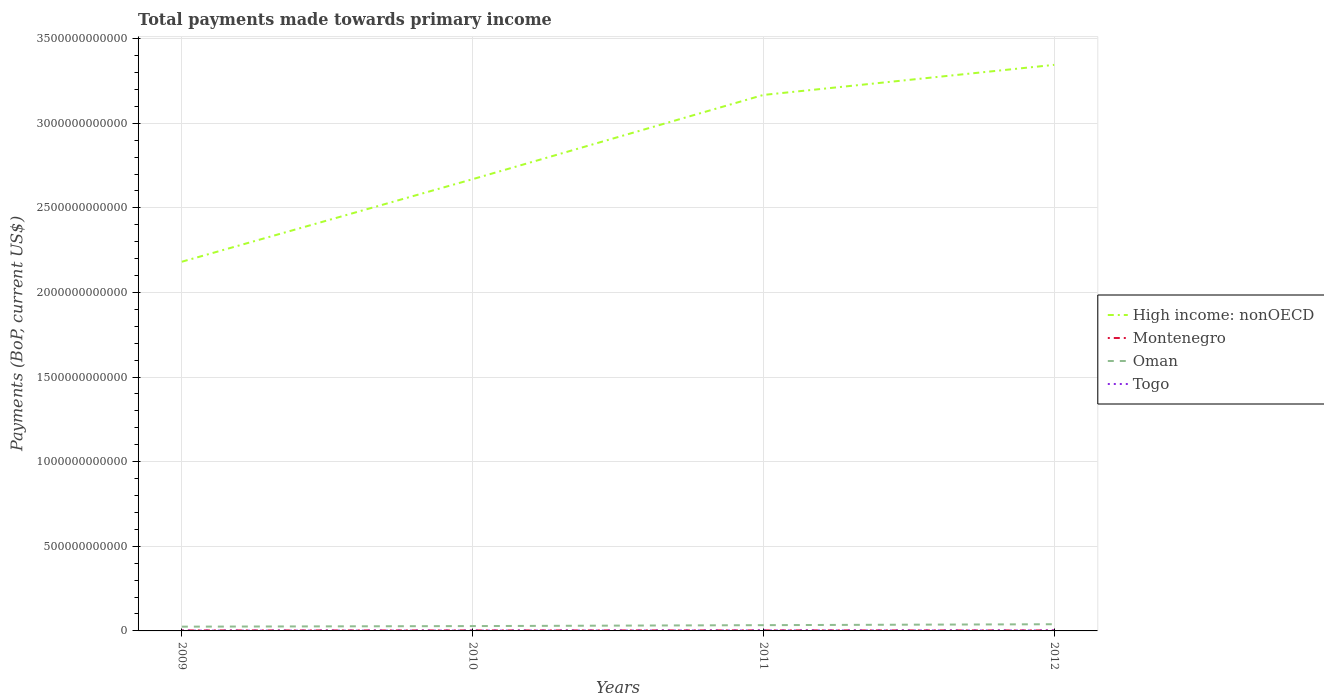How many different coloured lines are there?
Make the answer very short. 4. Is the number of lines equal to the number of legend labels?
Provide a succinct answer. Yes. Across all years, what is the maximum total payments made towards primary income in Oman?
Ensure brevity in your answer.  2.52e+1. In which year was the total payments made towards primary income in Togo maximum?
Your answer should be compact. 2009. What is the total total payments made towards primary income in Oman in the graph?
Offer a terse response. -1.10e+1. What is the difference between the highest and the second highest total payments made towards primary income in Montenegro?
Provide a short and direct response. 3.26e+08. What is the difference between the highest and the lowest total payments made towards primary income in High income: nonOECD?
Provide a short and direct response. 2. How many years are there in the graph?
Offer a terse response. 4. What is the difference between two consecutive major ticks on the Y-axis?
Offer a terse response. 5.00e+11. Does the graph contain any zero values?
Your response must be concise. No. Does the graph contain grids?
Provide a short and direct response. Yes. Where does the legend appear in the graph?
Your answer should be very brief. Center right. How many legend labels are there?
Your response must be concise. 4. What is the title of the graph?
Provide a short and direct response. Total payments made towards primary income. Does "Jordan" appear as one of the legend labels in the graph?
Give a very brief answer. No. What is the label or title of the X-axis?
Your answer should be compact. Years. What is the label or title of the Y-axis?
Your answer should be compact. Payments (BoP, current US$). What is the Payments (BoP, current US$) of High income: nonOECD in 2009?
Offer a very short reply. 2.18e+12. What is the Payments (BoP, current US$) of Montenegro in 2009?
Provide a short and direct response. 2.93e+09. What is the Payments (BoP, current US$) in Oman in 2009?
Your answer should be compact. 2.52e+1. What is the Payments (BoP, current US$) in Togo in 2009?
Make the answer very short. 1.78e+09. What is the Payments (BoP, current US$) of High income: nonOECD in 2010?
Keep it short and to the point. 2.67e+12. What is the Payments (BoP, current US$) of Montenegro in 2010?
Offer a terse response. 2.83e+09. What is the Payments (BoP, current US$) of Oman in 2010?
Offer a terse response. 2.86e+1. What is the Payments (BoP, current US$) in Togo in 2010?
Keep it short and to the point. 1.95e+09. What is the Payments (BoP, current US$) in High income: nonOECD in 2011?
Provide a succinct answer. 3.17e+12. What is the Payments (BoP, current US$) in Montenegro in 2011?
Ensure brevity in your answer.  3.15e+09. What is the Payments (BoP, current US$) of Oman in 2011?
Offer a terse response. 3.41e+1. What is the Payments (BoP, current US$) of Togo in 2011?
Give a very brief answer. 2.65e+09. What is the Payments (BoP, current US$) in High income: nonOECD in 2012?
Provide a succinct answer. 3.34e+12. What is the Payments (BoP, current US$) in Montenegro in 2012?
Provide a succinct answer. 2.92e+09. What is the Payments (BoP, current US$) in Oman in 2012?
Provide a short and direct response. 3.96e+1. What is the Payments (BoP, current US$) of Togo in 2012?
Offer a very short reply. 2.54e+09. Across all years, what is the maximum Payments (BoP, current US$) in High income: nonOECD?
Ensure brevity in your answer.  3.34e+12. Across all years, what is the maximum Payments (BoP, current US$) in Montenegro?
Keep it short and to the point. 3.15e+09. Across all years, what is the maximum Payments (BoP, current US$) in Oman?
Provide a succinct answer. 3.96e+1. Across all years, what is the maximum Payments (BoP, current US$) in Togo?
Make the answer very short. 2.65e+09. Across all years, what is the minimum Payments (BoP, current US$) in High income: nonOECD?
Offer a very short reply. 2.18e+12. Across all years, what is the minimum Payments (BoP, current US$) in Montenegro?
Offer a very short reply. 2.83e+09. Across all years, what is the minimum Payments (BoP, current US$) of Oman?
Make the answer very short. 2.52e+1. Across all years, what is the minimum Payments (BoP, current US$) of Togo?
Offer a terse response. 1.78e+09. What is the total Payments (BoP, current US$) in High income: nonOECD in the graph?
Give a very brief answer. 1.14e+13. What is the total Payments (BoP, current US$) in Montenegro in the graph?
Your answer should be compact. 1.18e+1. What is the total Payments (BoP, current US$) in Oman in the graph?
Keep it short and to the point. 1.27e+11. What is the total Payments (BoP, current US$) in Togo in the graph?
Offer a very short reply. 8.92e+09. What is the difference between the Payments (BoP, current US$) of High income: nonOECD in 2009 and that in 2010?
Provide a succinct answer. -4.88e+11. What is the difference between the Payments (BoP, current US$) of Montenegro in 2009 and that in 2010?
Keep it short and to the point. 1.07e+08. What is the difference between the Payments (BoP, current US$) of Oman in 2009 and that in 2010?
Ensure brevity in your answer.  -3.38e+09. What is the difference between the Payments (BoP, current US$) of Togo in 2009 and that in 2010?
Provide a succinct answer. -1.74e+08. What is the difference between the Payments (BoP, current US$) in High income: nonOECD in 2009 and that in 2011?
Ensure brevity in your answer.  -9.86e+11. What is the difference between the Payments (BoP, current US$) in Montenegro in 2009 and that in 2011?
Your answer should be very brief. -2.19e+08. What is the difference between the Payments (BoP, current US$) of Oman in 2009 and that in 2011?
Your answer should be very brief. -8.90e+09. What is the difference between the Payments (BoP, current US$) of Togo in 2009 and that in 2011?
Make the answer very short. -8.74e+08. What is the difference between the Payments (BoP, current US$) in High income: nonOECD in 2009 and that in 2012?
Keep it short and to the point. -1.16e+12. What is the difference between the Payments (BoP, current US$) of Montenegro in 2009 and that in 2012?
Offer a terse response. 1.51e+07. What is the difference between the Payments (BoP, current US$) of Oman in 2009 and that in 2012?
Make the answer very short. -1.43e+1. What is the difference between the Payments (BoP, current US$) of Togo in 2009 and that in 2012?
Offer a terse response. -7.64e+08. What is the difference between the Payments (BoP, current US$) of High income: nonOECD in 2010 and that in 2011?
Offer a terse response. -4.98e+11. What is the difference between the Payments (BoP, current US$) of Montenegro in 2010 and that in 2011?
Offer a terse response. -3.26e+08. What is the difference between the Payments (BoP, current US$) in Oman in 2010 and that in 2011?
Offer a very short reply. -5.52e+09. What is the difference between the Payments (BoP, current US$) in Togo in 2010 and that in 2011?
Offer a very short reply. -7.00e+08. What is the difference between the Payments (BoP, current US$) of High income: nonOECD in 2010 and that in 2012?
Your response must be concise. -6.76e+11. What is the difference between the Payments (BoP, current US$) in Montenegro in 2010 and that in 2012?
Make the answer very short. -9.16e+07. What is the difference between the Payments (BoP, current US$) in Oman in 2010 and that in 2012?
Ensure brevity in your answer.  -1.10e+1. What is the difference between the Payments (BoP, current US$) of Togo in 2010 and that in 2012?
Provide a short and direct response. -5.90e+08. What is the difference between the Payments (BoP, current US$) in High income: nonOECD in 2011 and that in 2012?
Give a very brief answer. -1.78e+11. What is the difference between the Payments (BoP, current US$) of Montenegro in 2011 and that in 2012?
Provide a short and direct response. 2.34e+08. What is the difference between the Payments (BoP, current US$) in Oman in 2011 and that in 2012?
Your answer should be very brief. -5.45e+09. What is the difference between the Payments (BoP, current US$) in Togo in 2011 and that in 2012?
Ensure brevity in your answer.  1.10e+08. What is the difference between the Payments (BoP, current US$) in High income: nonOECD in 2009 and the Payments (BoP, current US$) in Montenegro in 2010?
Provide a succinct answer. 2.18e+12. What is the difference between the Payments (BoP, current US$) in High income: nonOECD in 2009 and the Payments (BoP, current US$) in Oman in 2010?
Make the answer very short. 2.15e+12. What is the difference between the Payments (BoP, current US$) in High income: nonOECD in 2009 and the Payments (BoP, current US$) in Togo in 2010?
Provide a succinct answer. 2.18e+12. What is the difference between the Payments (BoP, current US$) of Montenegro in 2009 and the Payments (BoP, current US$) of Oman in 2010?
Your answer should be very brief. -2.57e+1. What is the difference between the Payments (BoP, current US$) of Montenegro in 2009 and the Payments (BoP, current US$) of Togo in 2010?
Give a very brief answer. 9.82e+08. What is the difference between the Payments (BoP, current US$) in Oman in 2009 and the Payments (BoP, current US$) in Togo in 2010?
Provide a succinct answer. 2.33e+1. What is the difference between the Payments (BoP, current US$) in High income: nonOECD in 2009 and the Payments (BoP, current US$) in Montenegro in 2011?
Your answer should be very brief. 2.18e+12. What is the difference between the Payments (BoP, current US$) of High income: nonOECD in 2009 and the Payments (BoP, current US$) of Oman in 2011?
Offer a terse response. 2.15e+12. What is the difference between the Payments (BoP, current US$) in High income: nonOECD in 2009 and the Payments (BoP, current US$) in Togo in 2011?
Give a very brief answer. 2.18e+12. What is the difference between the Payments (BoP, current US$) of Montenegro in 2009 and the Payments (BoP, current US$) of Oman in 2011?
Your response must be concise. -3.12e+1. What is the difference between the Payments (BoP, current US$) in Montenegro in 2009 and the Payments (BoP, current US$) in Togo in 2011?
Make the answer very short. 2.82e+08. What is the difference between the Payments (BoP, current US$) of Oman in 2009 and the Payments (BoP, current US$) of Togo in 2011?
Make the answer very short. 2.26e+1. What is the difference between the Payments (BoP, current US$) in High income: nonOECD in 2009 and the Payments (BoP, current US$) in Montenegro in 2012?
Your response must be concise. 2.18e+12. What is the difference between the Payments (BoP, current US$) in High income: nonOECD in 2009 and the Payments (BoP, current US$) in Oman in 2012?
Your response must be concise. 2.14e+12. What is the difference between the Payments (BoP, current US$) in High income: nonOECD in 2009 and the Payments (BoP, current US$) in Togo in 2012?
Your answer should be very brief. 2.18e+12. What is the difference between the Payments (BoP, current US$) of Montenegro in 2009 and the Payments (BoP, current US$) of Oman in 2012?
Make the answer very short. -3.66e+1. What is the difference between the Payments (BoP, current US$) in Montenegro in 2009 and the Payments (BoP, current US$) in Togo in 2012?
Provide a succinct answer. 3.92e+08. What is the difference between the Payments (BoP, current US$) of Oman in 2009 and the Payments (BoP, current US$) of Togo in 2012?
Your answer should be very brief. 2.27e+1. What is the difference between the Payments (BoP, current US$) in High income: nonOECD in 2010 and the Payments (BoP, current US$) in Montenegro in 2011?
Offer a very short reply. 2.67e+12. What is the difference between the Payments (BoP, current US$) of High income: nonOECD in 2010 and the Payments (BoP, current US$) of Oman in 2011?
Ensure brevity in your answer.  2.64e+12. What is the difference between the Payments (BoP, current US$) of High income: nonOECD in 2010 and the Payments (BoP, current US$) of Togo in 2011?
Offer a very short reply. 2.67e+12. What is the difference between the Payments (BoP, current US$) of Montenegro in 2010 and the Payments (BoP, current US$) of Oman in 2011?
Your answer should be very brief. -3.13e+1. What is the difference between the Payments (BoP, current US$) of Montenegro in 2010 and the Payments (BoP, current US$) of Togo in 2011?
Your answer should be very brief. 1.75e+08. What is the difference between the Payments (BoP, current US$) of Oman in 2010 and the Payments (BoP, current US$) of Togo in 2011?
Give a very brief answer. 2.59e+1. What is the difference between the Payments (BoP, current US$) in High income: nonOECD in 2010 and the Payments (BoP, current US$) in Montenegro in 2012?
Your answer should be compact. 2.67e+12. What is the difference between the Payments (BoP, current US$) in High income: nonOECD in 2010 and the Payments (BoP, current US$) in Oman in 2012?
Your answer should be compact. 2.63e+12. What is the difference between the Payments (BoP, current US$) in High income: nonOECD in 2010 and the Payments (BoP, current US$) in Togo in 2012?
Keep it short and to the point. 2.67e+12. What is the difference between the Payments (BoP, current US$) of Montenegro in 2010 and the Payments (BoP, current US$) of Oman in 2012?
Provide a short and direct response. -3.67e+1. What is the difference between the Payments (BoP, current US$) in Montenegro in 2010 and the Payments (BoP, current US$) in Togo in 2012?
Provide a short and direct response. 2.85e+08. What is the difference between the Payments (BoP, current US$) in Oman in 2010 and the Payments (BoP, current US$) in Togo in 2012?
Offer a terse response. 2.60e+1. What is the difference between the Payments (BoP, current US$) of High income: nonOECD in 2011 and the Payments (BoP, current US$) of Montenegro in 2012?
Offer a terse response. 3.16e+12. What is the difference between the Payments (BoP, current US$) of High income: nonOECD in 2011 and the Payments (BoP, current US$) of Oman in 2012?
Your response must be concise. 3.13e+12. What is the difference between the Payments (BoP, current US$) in High income: nonOECD in 2011 and the Payments (BoP, current US$) in Togo in 2012?
Make the answer very short. 3.16e+12. What is the difference between the Payments (BoP, current US$) in Montenegro in 2011 and the Payments (BoP, current US$) in Oman in 2012?
Ensure brevity in your answer.  -3.64e+1. What is the difference between the Payments (BoP, current US$) in Montenegro in 2011 and the Payments (BoP, current US$) in Togo in 2012?
Ensure brevity in your answer.  6.11e+08. What is the difference between the Payments (BoP, current US$) in Oman in 2011 and the Payments (BoP, current US$) in Togo in 2012?
Offer a terse response. 3.16e+1. What is the average Payments (BoP, current US$) in High income: nonOECD per year?
Ensure brevity in your answer.  2.84e+12. What is the average Payments (BoP, current US$) of Montenegro per year?
Offer a very short reply. 2.96e+09. What is the average Payments (BoP, current US$) of Oman per year?
Keep it short and to the point. 3.19e+1. What is the average Payments (BoP, current US$) of Togo per year?
Offer a terse response. 2.23e+09. In the year 2009, what is the difference between the Payments (BoP, current US$) in High income: nonOECD and Payments (BoP, current US$) in Montenegro?
Ensure brevity in your answer.  2.18e+12. In the year 2009, what is the difference between the Payments (BoP, current US$) of High income: nonOECD and Payments (BoP, current US$) of Oman?
Offer a terse response. 2.16e+12. In the year 2009, what is the difference between the Payments (BoP, current US$) in High income: nonOECD and Payments (BoP, current US$) in Togo?
Your answer should be compact. 2.18e+12. In the year 2009, what is the difference between the Payments (BoP, current US$) in Montenegro and Payments (BoP, current US$) in Oman?
Make the answer very short. -2.23e+1. In the year 2009, what is the difference between the Payments (BoP, current US$) of Montenegro and Payments (BoP, current US$) of Togo?
Keep it short and to the point. 1.16e+09. In the year 2009, what is the difference between the Payments (BoP, current US$) in Oman and Payments (BoP, current US$) in Togo?
Provide a short and direct response. 2.34e+1. In the year 2010, what is the difference between the Payments (BoP, current US$) in High income: nonOECD and Payments (BoP, current US$) in Montenegro?
Ensure brevity in your answer.  2.67e+12. In the year 2010, what is the difference between the Payments (BoP, current US$) of High income: nonOECD and Payments (BoP, current US$) of Oman?
Your response must be concise. 2.64e+12. In the year 2010, what is the difference between the Payments (BoP, current US$) of High income: nonOECD and Payments (BoP, current US$) of Togo?
Make the answer very short. 2.67e+12. In the year 2010, what is the difference between the Payments (BoP, current US$) in Montenegro and Payments (BoP, current US$) in Oman?
Keep it short and to the point. -2.58e+1. In the year 2010, what is the difference between the Payments (BoP, current US$) in Montenegro and Payments (BoP, current US$) in Togo?
Provide a succinct answer. 8.75e+08. In the year 2010, what is the difference between the Payments (BoP, current US$) of Oman and Payments (BoP, current US$) of Togo?
Give a very brief answer. 2.66e+1. In the year 2011, what is the difference between the Payments (BoP, current US$) of High income: nonOECD and Payments (BoP, current US$) of Montenegro?
Make the answer very short. 3.16e+12. In the year 2011, what is the difference between the Payments (BoP, current US$) of High income: nonOECD and Payments (BoP, current US$) of Oman?
Offer a terse response. 3.13e+12. In the year 2011, what is the difference between the Payments (BoP, current US$) in High income: nonOECD and Payments (BoP, current US$) in Togo?
Give a very brief answer. 3.16e+12. In the year 2011, what is the difference between the Payments (BoP, current US$) in Montenegro and Payments (BoP, current US$) in Oman?
Your response must be concise. -3.10e+1. In the year 2011, what is the difference between the Payments (BoP, current US$) in Montenegro and Payments (BoP, current US$) in Togo?
Your response must be concise. 5.01e+08. In the year 2011, what is the difference between the Payments (BoP, current US$) in Oman and Payments (BoP, current US$) in Togo?
Provide a succinct answer. 3.15e+1. In the year 2012, what is the difference between the Payments (BoP, current US$) in High income: nonOECD and Payments (BoP, current US$) in Montenegro?
Your answer should be compact. 3.34e+12. In the year 2012, what is the difference between the Payments (BoP, current US$) in High income: nonOECD and Payments (BoP, current US$) in Oman?
Your response must be concise. 3.31e+12. In the year 2012, what is the difference between the Payments (BoP, current US$) of High income: nonOECD and Payments (BoP, current US$) of Togo?
Your answer should be compact. 3.34e+12. In the year 2012, what is the difference between the Payments (BoP, current US$) of Montenegro and Payments (BoP, current US$) of Oman?
Offer a very short reply. -3.66e+1. In the year 2012, what is the difference between the Payments (BoP, current US$) of Montenegro and Payments (BoP, current US$) of Togo?
Give a very brief answer. 3.77e+08. In the year 2012, what is the difference between the Payments (BoP, current US$) of Oman and Payments (BoP, current US$) of Togo?
Provide a succinct answer. 3.70e+1. What is the ratio of the Payments (BoP, current US$) in High income: nonOECD in 2009 to that in 2010?
Your response must be concise. 0.82. What is the ratio of the Payments (BoP, current US$) of Montenegro in 2009 to that in 2010?
Provide a succinct answer. 1.04. What is the ratio of the Payments (BoP, current US$) of Oman in 2009 to that in 2010?
Keep it short and to the point. 0.88. What is the ratio of the Payments (BoP, current US$) of Togo in 2009 to that in 2010?
Provide a short and direct response. 0.91. What is the ratio of the Payments (BoP, current US$) in High income: nonOECD in 2009 to that in 2011?
Your answer should be very brief. 0.69. What is the ratio of the Payments (BoP, current US$) of Montenegro in 2009 to that in 2011?
Ensure brevity in your answer.  0.93. What is the ratio of the Payments (BoP, current US$) in Oman in 2009 to that in 2011?
Offer a very short reply. 0.74. What is the ratio of the Payments (BoP, current US$) of Togo in 2009 to that in 2011?
Provide a short and direct response. 0.67. What is the ratio of the Payments (BoP, current US$) of High income: nonOECD in 2009 to that in 2012?
Offer a very short reply. 0.65. What is the ratio of the Payments (BoP, current US$) of Montenegro in 2009 to that in 2012?
Your answer should be very brief. 1.01. What is the ratio of the Payments (BoP, current US$) of Oman in 2009 to that in 2012?
Keep it short and to the point. 0.64. What is the ratio of the Payments (BoP, current US$) in Togo in 2009 to that in 2012?
Make the answer very short. 0.7. What is the ratio of the Payments (BoP, current US$) in High income: nonOECD in 2010 to that in 2011?
Keep it short and to the point. 0.84. What is the ratio of the Payments (BoP, current US$) in Montenegro in 2010 to that in 2011?
Ensure brevity in your answer.  0.9. What is the ratio of the Payments (BoP, current US$) in Oman in 2010 to that in 2011?
Ensure brevity in your answer.  0.84. What is the ratio of the Payments (BoP, current US$) in Togo in 2010 to that in 2011?
Ensure brevity in your answer.  0.74. What is the ratio of the Payments (BoP, current US$) of High income: nonOECD in 2010 to that in 2012?
Provide a short and direct response. 0.8. What is the ratio of the Payments (BoP, current US$) in Montenegro in 2010 to that in 2012?
Your answer should be compact. 0.97. What is the ratio of the Payments (BoP, current US$) of Oman in 2010 to that in 2012?
Offer a very short reply. 0.72. What is the ratio of the Payments (BoP, current US$) in Togo in 2010 to that in 2012?
Give a very brief answer. 0.77. What is the ratio of the Payments (BoP, current US$) of High income: nonOECD in 2011 to that in 2012?
Provide a short and direct response. 0.95. What is the ratio of the Payments (BoP, current US$) in Montenegro in 2011 to that in 2012?
Your answer should be compact. 1.08. What is the ratio of the Payments (BoP, current US$) in Oman in 2011 to that in 2012?
Give a very brief answer. 0.86. What is the ratio of the Payments (BoP, current US$) of Togo in 2011 to that in 2012?
Your answer should be very brief. 1.04. What is the difference between the highest and the second highest Payments (BoP, current US$) in High income: nonOECD?
Your answer should be very brief. 1.78e+11. What is the difference between the highest and the second highest Payments (BoP, current US$) of Montenegro?
Your answer should be very brief. 2.19e+08. What is the difference between the highest and the second highest Payments (BoP, current US$) of Oman?
Keep it short and to the point. 5.45e+09. What is the difference between the highest and the second highest Payments (BoP, current US$) in Togo?
Provide a short and direct response. 1.10e+08. What is the difference between the highest and the lowest Payments (BoP, current US$) of High income: nonOECD?
Your response must be concise. 1.16e+12. What is the difference between the highest and the lowest Payments (BoP, current US$) in Montenegro?
Provide a short and direct response. 3.26e+08. What is the difference between the highest and the lowest Payments (BoP, current US$) of Oman?
Your answer should be compact. 1.43e+1. What is the difference between the highest and the lowest Payments (BoP, current US$) in Togo?
Keep it short and to the point. 8.74e+08. 